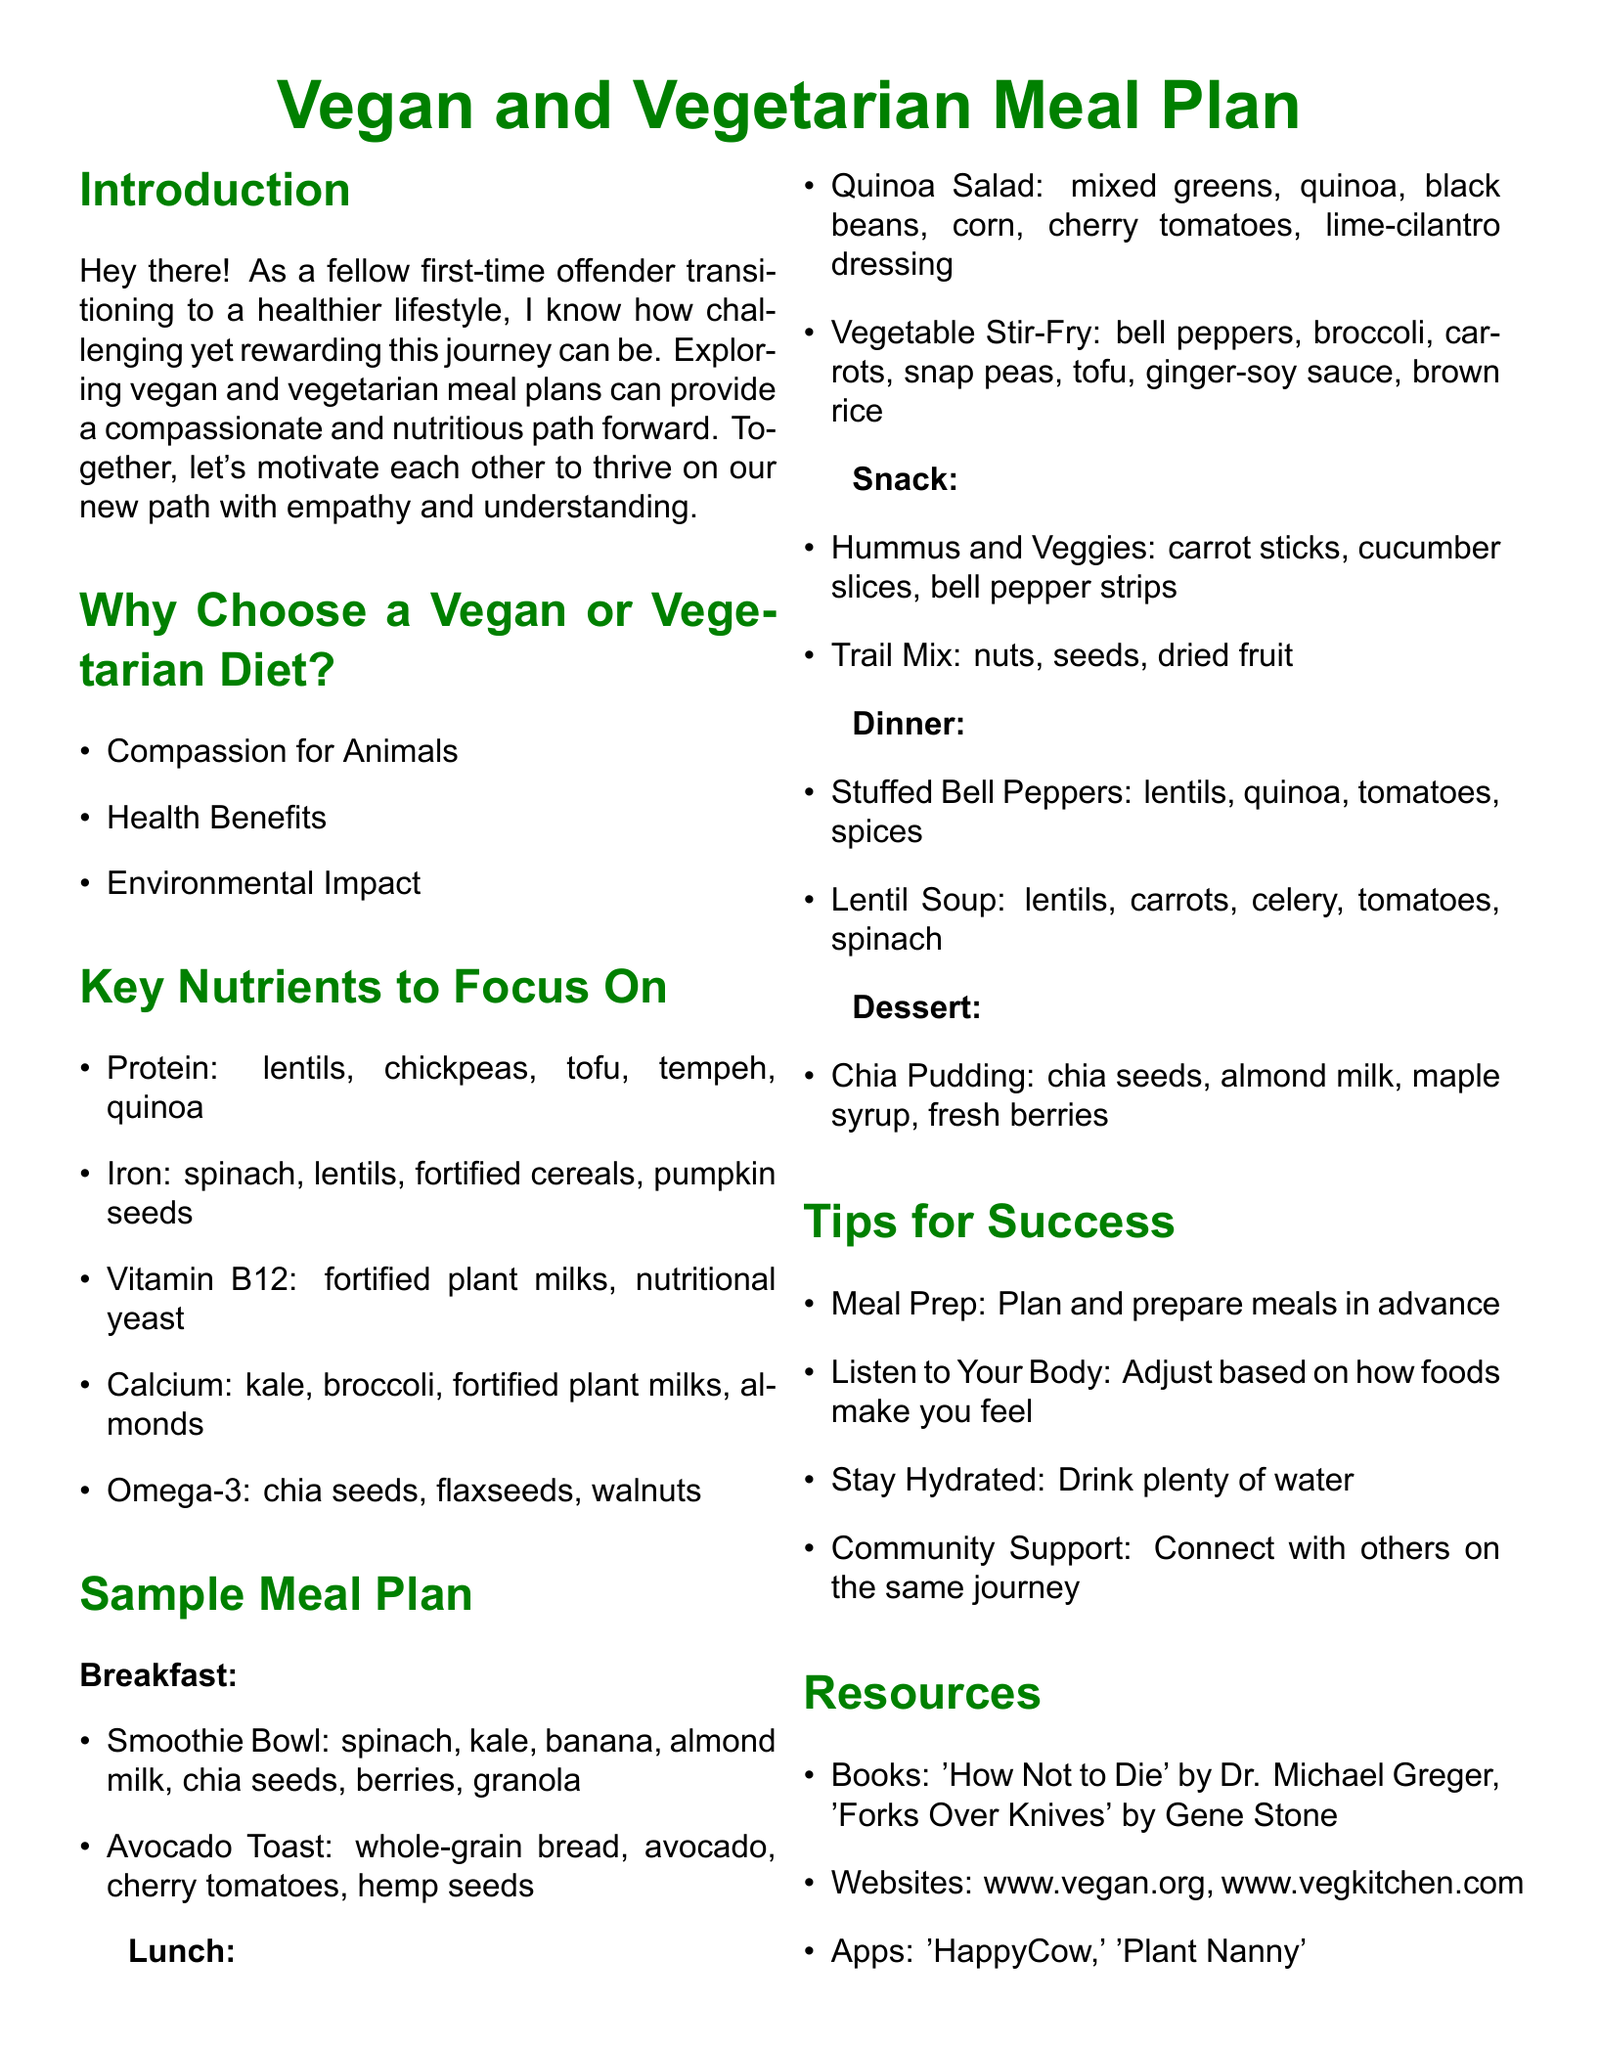What is a key reason to choose a vegan diet? The document lists compassion for animals, health benefits, and environmental impact as key reasons to choose a vegan diet.
Answer: Compassion for Animals What nutrient is fortified in plant milks? Vitamin B12 is mentioned as being fortified in plant milks.
Answer: Vitamin B12 What is one of the ingredients in the smoothie bowl? The smoothie bowl contains spinach, kale, banana, almond milk, chia seeds, berries, granola, but only one is required for the answer.
Answer: Spinach How many meals are specified in the sample meal plan? The sample meal plan includes five meals: Breakfast, Lunch, Snack, Dinner, and Dessert.
Answer: Five What is a suggested tip for success in this meal plan? The document suggests various tips, one of which is meal prep, preparing meals in advance.
Answer: Meal Prep Which book is recommended in the resources section? The document lists 'How Not to Die' by Dr. Michael Greger as one of the recommended books.
Answer: How Not to Die What is the main color used in the document? The document specifies the main color as green, which is used for titles and headings.
Answer: Green What food item is suggested for a healthy snack? Hummus and veggies and trail mix are proposed as healthy snacks in the meal plan.
Answer: Hummus and Veggies 